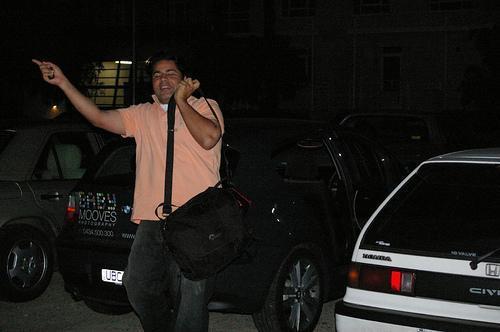How many cars are in the picture?
Give a very brief answer. 3. How many giraffes do you see?
Give a very brief answer. 0. 